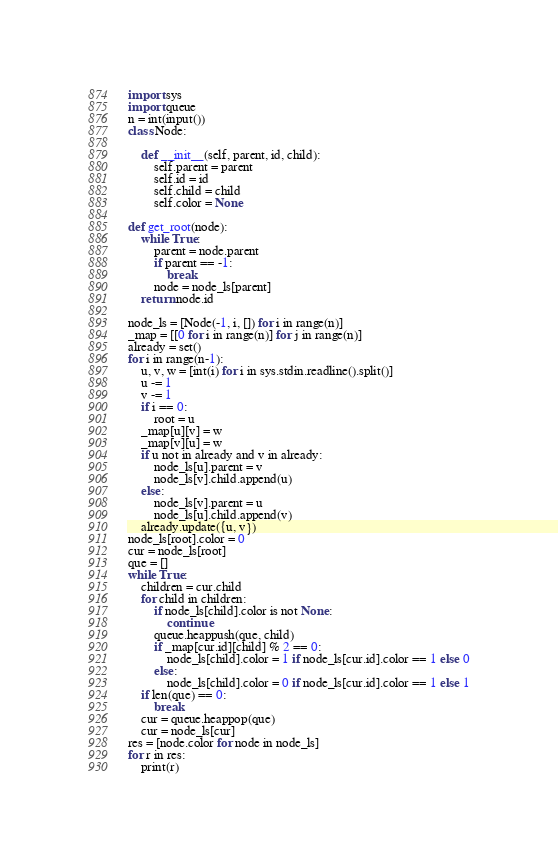<code> <loc_0><loc_0><loc_500><loc_500><_Python_>import sys
import queue
n = int(input())
class Node:

    def __init__(self, parent, id, child):
        self.parent = parent
        self.id = id
        self.child = child
        self.color = None

def get_root(node):
    while True:
        parent = node.parent
        if parent == -1:
            break
        node = node_ls[parent]
    return node.id

node_ls = [Node(-1, i, []) for i in range(n)]
_map = [[0 for i in range(n)] for j in range(n)]
already = set()
for i in range(n-1):
    u, v, w = [int(i) for i in sys.stdin.readline().split()]
    u -= 1
    v -= 1
    if i == 0:
        root = u
    _map[u][v] = w
    _map[v][u] = w
    if u not in already and v in already:
        node_ls[u].parent = v
        node_ls[v].child.append(u)
    else:
        node_ls[v].parent = u
        node_ls[u].child.append(v)
    already.update({u, v})
node_ls[root].color = 0
cur = node_ls[root]
que = []
while True:
    children = cur.child
    for child in children:
        if node_ls[child].color is not None:
            continue
        queue.heappush(que, child)
        if _map[cur.id][child] % 2 == 0:
            node_ls[child].color = 1 if node_ls[cur.id].color == 1 else 0
        else:
            node_ls[child].color = 0 if node_ls[cur.id].color == 1 else 1
    if len(que) == 0:
        break
    cur = queue.heappop(que)
    cur = node_ls[cur]
res = [node.color for node in node_ls]
for r in res:
    print(r)</code> 